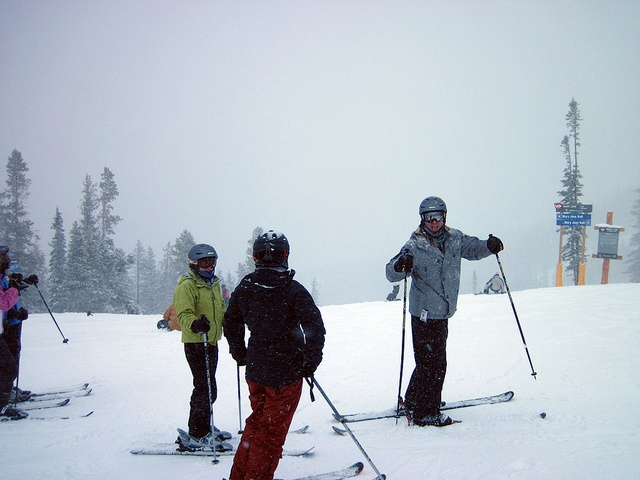Describe the objects in this image and their specific colors. I can see people in darkgray, black, maroon, white, and navy tones, people in darkgray, black, gray, darkblue, and navy tones, people in darkgray, black, gray, darkgreen, and white tones, people in darkgray, black, navy, gray, and purple tones, and skis in darkgray, lightgray, and gray tones in this image. 